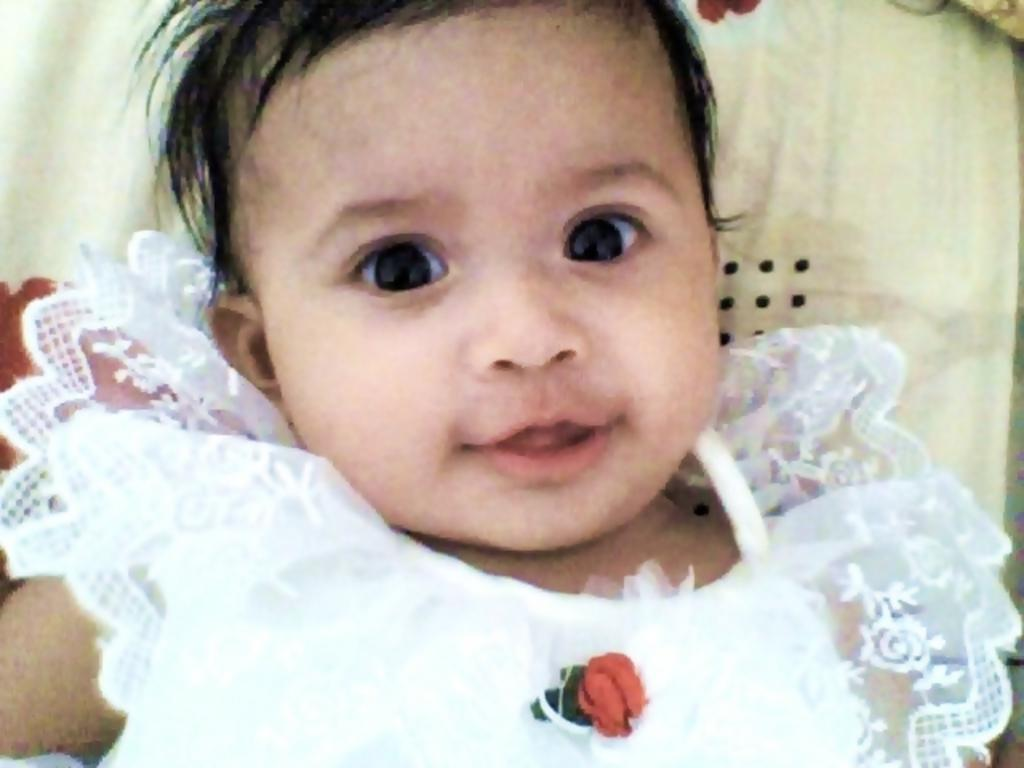What is the main subject of the image? There is a person in the image. What is the person wearing? The person is wearing a white dress. What expression does the person have? The person is smiling. What crime is the person committing in the image? There is no crime being committed in the image; the person is simply smiling while wearing a white dress. What is the name of the person in the image? The name of the person in the image is not mentioned or visible, so it cannot be determined. 